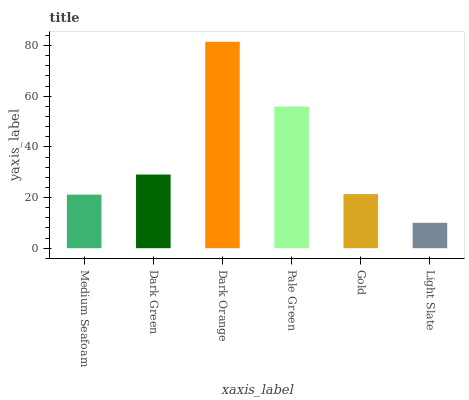Is Light Slate the minimum?
Answer yes or no. Yes. Is Dark Orange the maximum?
Answer yes or no. Yes. Is Dark Green the minimum?
Answer yes or no. No. Is Dark Green the maximum?
Answer yes or no. No. Is Dark Green greater than Medium Seafoam?
Answer yes or no. Yes. Is Medium Seafoam less than Dark Green?
Answer yes or no. Yes. Is Medium Seafoam greater than Dark Green?
Answer yes or no. No. Is Dark Green less than Medium Seafoam?
Answer yes or no. No. Is Dark Green the high median?
Answer yes or no. Yes. Is Gold the low median?
Answer yes or no. Yes. Is Dark Orange the high median?
Answer yes or no. No. Is Pale Green the low median?
Answer yes or no. No. 